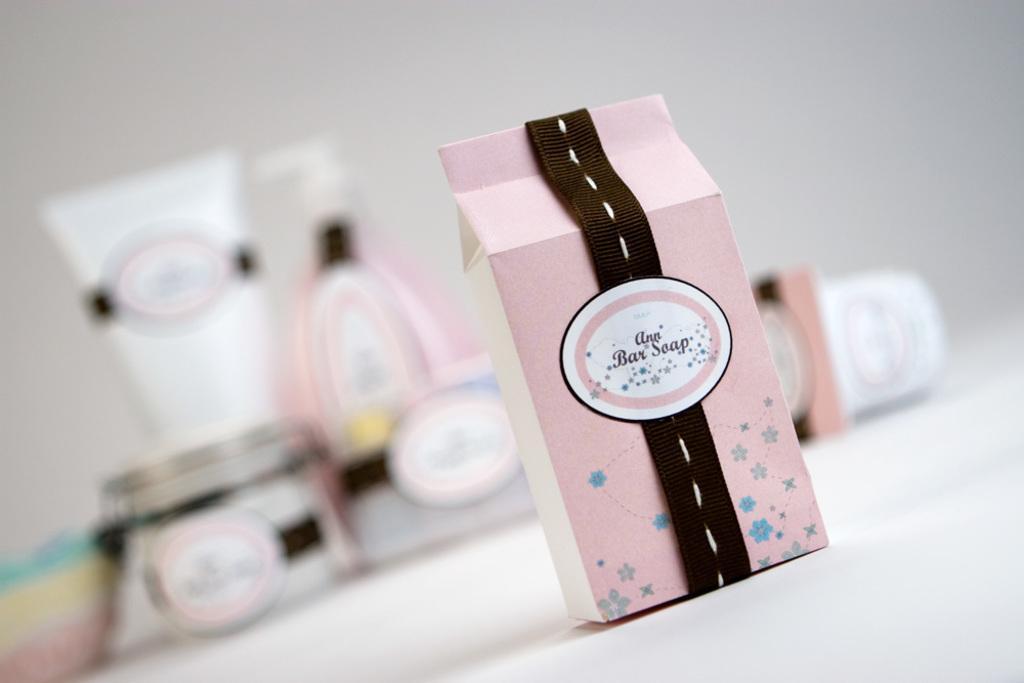In one or two sentences, can you explain what this image depicts? In this image we can see a box on a platform. There is a white background. Here can see boxes, tube, and bottles. 